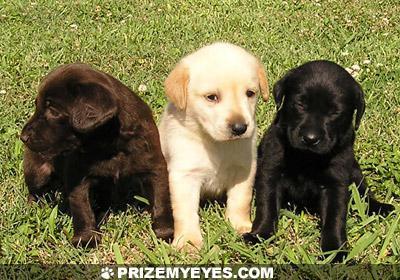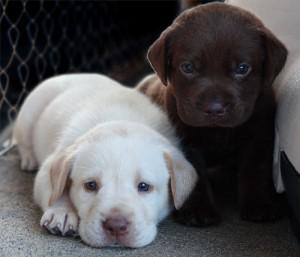The first image is the image on the left, the second image is the image on the right. Given the left and right images, does the statement "There are no more than two dogs in the right image." hold true? Answer yes or no. Yes. The first image is the image on the left, the second image is the image on the right. For the images displayed, is the sentence "There are five puppies in the image pair." factually correct? Answer yes or no. Yes. 